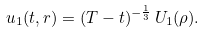<formula> <loc_0><loc_0><loc_500><loc_500>u _ { 1 } ( t , r ) = ( T - t ) ^ { - \frac { 1 } { 3 } } \, U _ { 1 } ( \rho ) .</formula> 